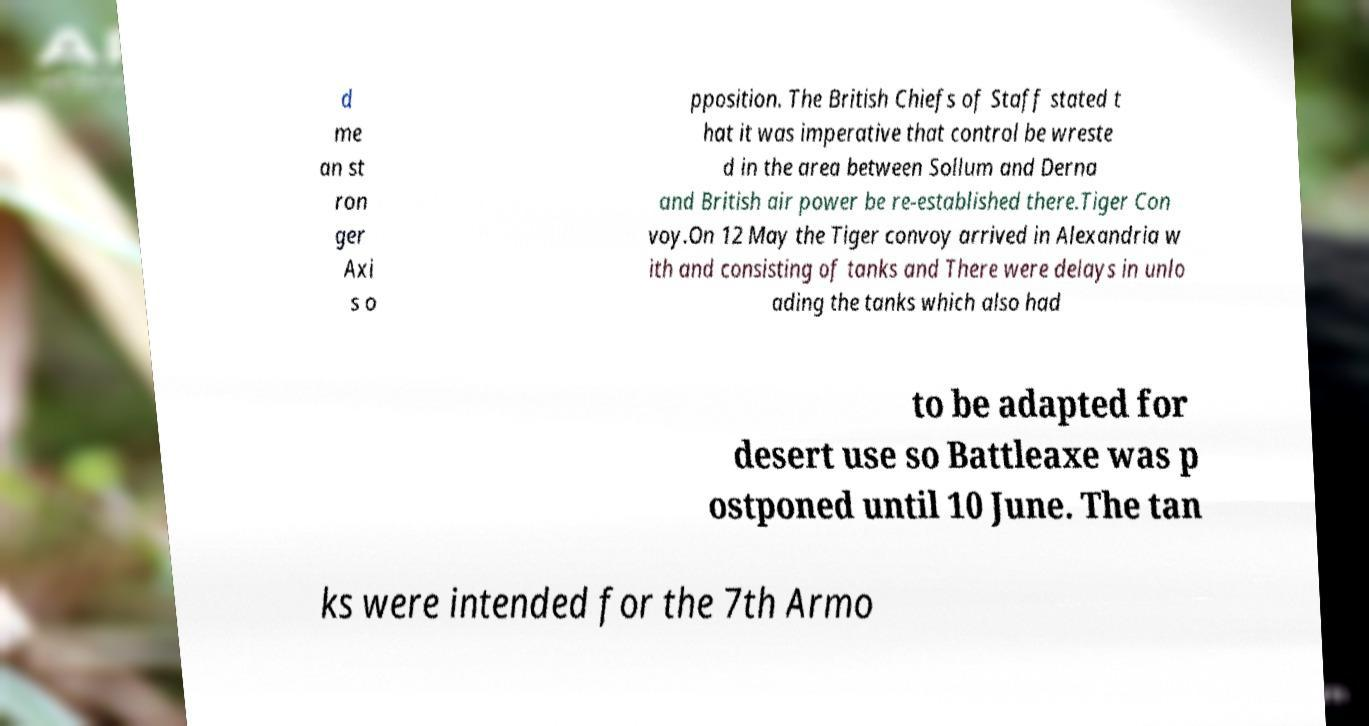Could you assist in decoding the text presented in this image and type it out clearly? d me an st ron ger Axi s o pposition. The British Chiefs of Staff stated t hat it was imperative that control be wreste d in the area between Sollum and Derna and British air power be re-established there.Tiger Con voy.On 12 May the Tiger convoy arrived in Alexandria w ith and consisting of tanks and There were delays in unlo ading the tanks which also had to be adapted for desert use so Battleaxe was p ostponed until 10 June. The tan ks were intended for the 7th Armo 